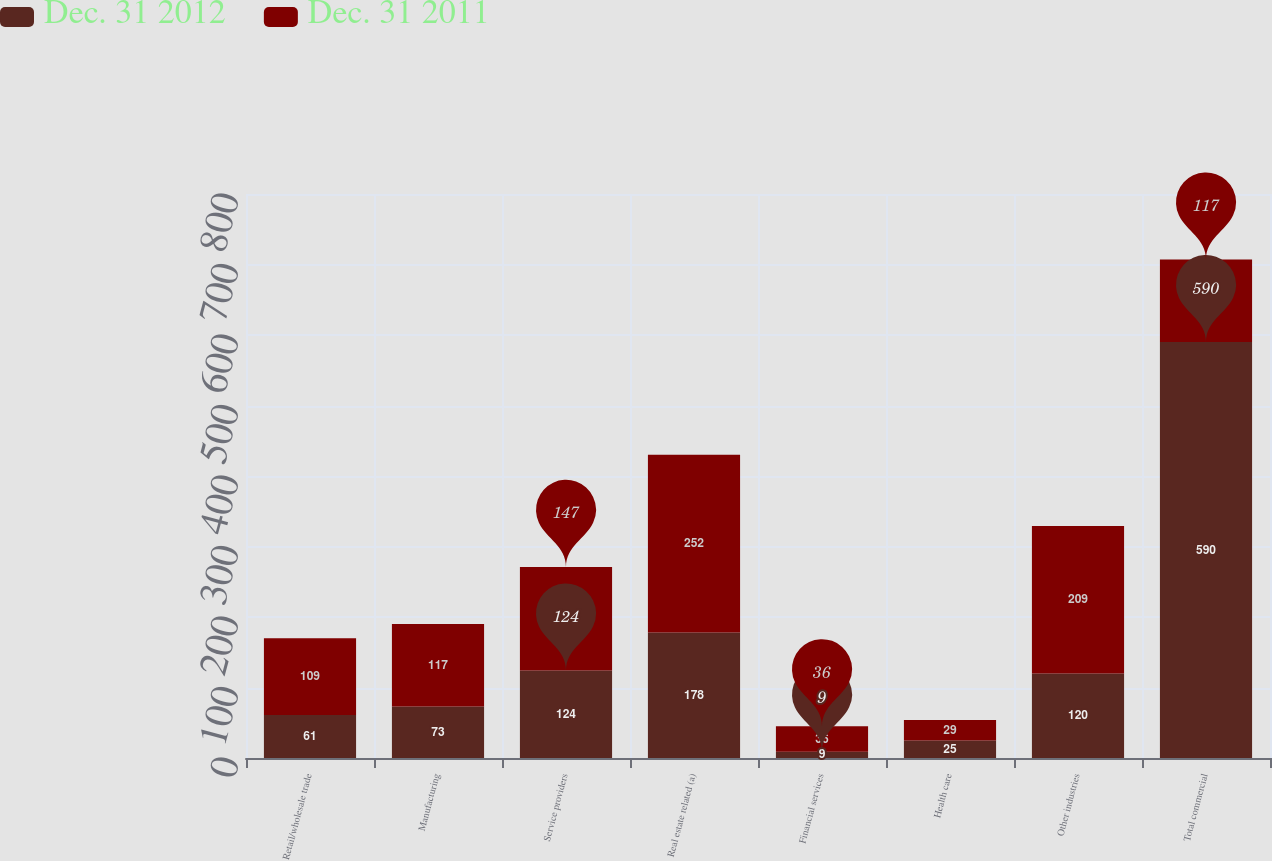Convert chart to OTSL. <chart><loc_0><loc_0><loc_500><loc_500><stacked_bar_chart><ecel><fcel>Retail/wholesale trade<fcel>Manufacturing<fcel>Service providers<fcel>Real estate related (a)<fcel>Financial services<fcel>Health care<fcel>Other industries<fcel>Total commercial<nl><fcel>Dec. 31 2012<fcel>61<fcel>73<fcel>124<fcel>178<fcel>9<fcel>25<fcel>120<fcel>590<nl><fcel>Dec. 31 2011<fcel>109<fcel>117<fcel>147<fcel>252<fcel>36<fcel>29<fcel>209<fcel>117<nl></chart> 